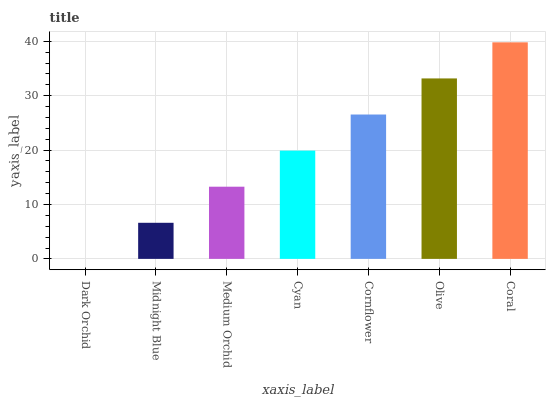Is Dark Orchid the minimum?
Answer yes or no. Yes. Is Coral the maximum?
Answer yes or no. Yes. Is Midnight Blue the minimum?
Answer yes or no. No. Is Midnight Blue the maximum?
Answer yes or no. No. Is Midnight Blue greater than Dark Orchid?
Answer yes or no. Yes. Is Dark Orchid less than Midnight Blue?
Answer yes or no. Yes. Is Dark Orchid greater than Midnight Blue?
Answer yes or no. No. Is Midnight Blue less than Dark Orchid?
Answer yes or no. No. Is Cyan the high median?
Answer yes or no. Yes. Is Cyan the low median?
Answer yes or no. Yes. Is Cornflower the high median?
Answer yes or no. No. Is Dark Orchid the low median?
Answer yes or no. No. 